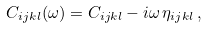Convert formula to latex. <formula><loc_0><loc_0><loc_500><loc_500>C _ { i j k l } ( \omega ) = C _ { i j k l } - i \omega \, \eta _ { i j k l } \, ,</formula> 